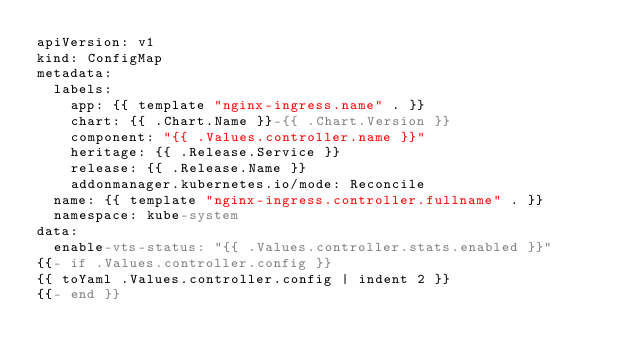Convert code to text. <code><loc_0><loc_0><loc_500><loc_500><_YAML_>apiVersion: v1
kind: ConfigMap
metadata:
  labels:
    app: {{ template "nginx-ingress.name" . }}
    chart: {{ .Chart.Name }}-{{ .Chart.Version }}
    component: "{{ .Values.controller.name }}"
    heritage: {{ .Release.Service }}
    release: {{ .Release.Name }}
    addonmanager.kubernetes.io/mode: Reconcile
  name: {{ template "nginx-ingress.controller.fullname" . }}
  namespace: kube-system
data:
  enable-vts-status: "{{ .Values.controller.stats.enabled }}"
{{- if .Values.controller.config }}
{{ toYaml .Values.controller.config | indent 2 }}
{{- end }}
</code> 